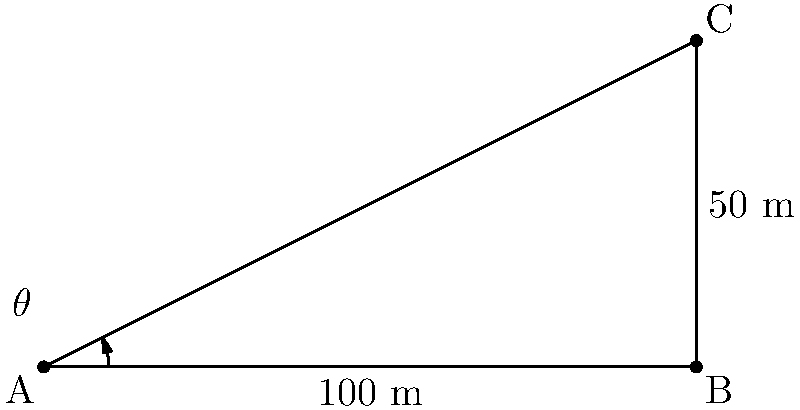As part of your citizen science project tracking bird migration, you observe a rare species flying at a constant altitude. From your observation point A on the ground, you measure the distance to a point directly below the bird (point B) to be 100 meters. Using a clinometer, you determine that the bird's elevation above the horizon is 50 meters. What is the angle of elevation ($\theta$) from your observation point to the bird? To solve this problem, we can use trigonometry, specifically the tangent function. Let's approach this step-by-step:

1) We have a right triangle ABC, where:
   - A is our observation point
   - B is the point directly below the bird
   - C is the position of the bird

2) We know:
   - The adjacent side (AB) = 100 meters
   - The opposite side (BC) = 50 meters

3) The tangent of an angle is defined as the ratio of the opposite side to the adjacent side:

   $\tan(\theta) = \frac{\text{opposite}}{\text{adjacent}}$

4) Substituting our known values:

   $\tan(\theta) = \frac{50}{100} = 0.5$

5) To find $\theta$, we need to use the inverse tangent (arctan or $\tan^{-1}$):

   $\theta = \tan^{-1}(0.5)$

6) Using a calculator or trigonometric tables:

   $\theta \approx 26.57^\circ$

Therefore, the angle of elevation from the observation point to the bird is approximately 26.57°.
Answer: $26.57^\circ$ 